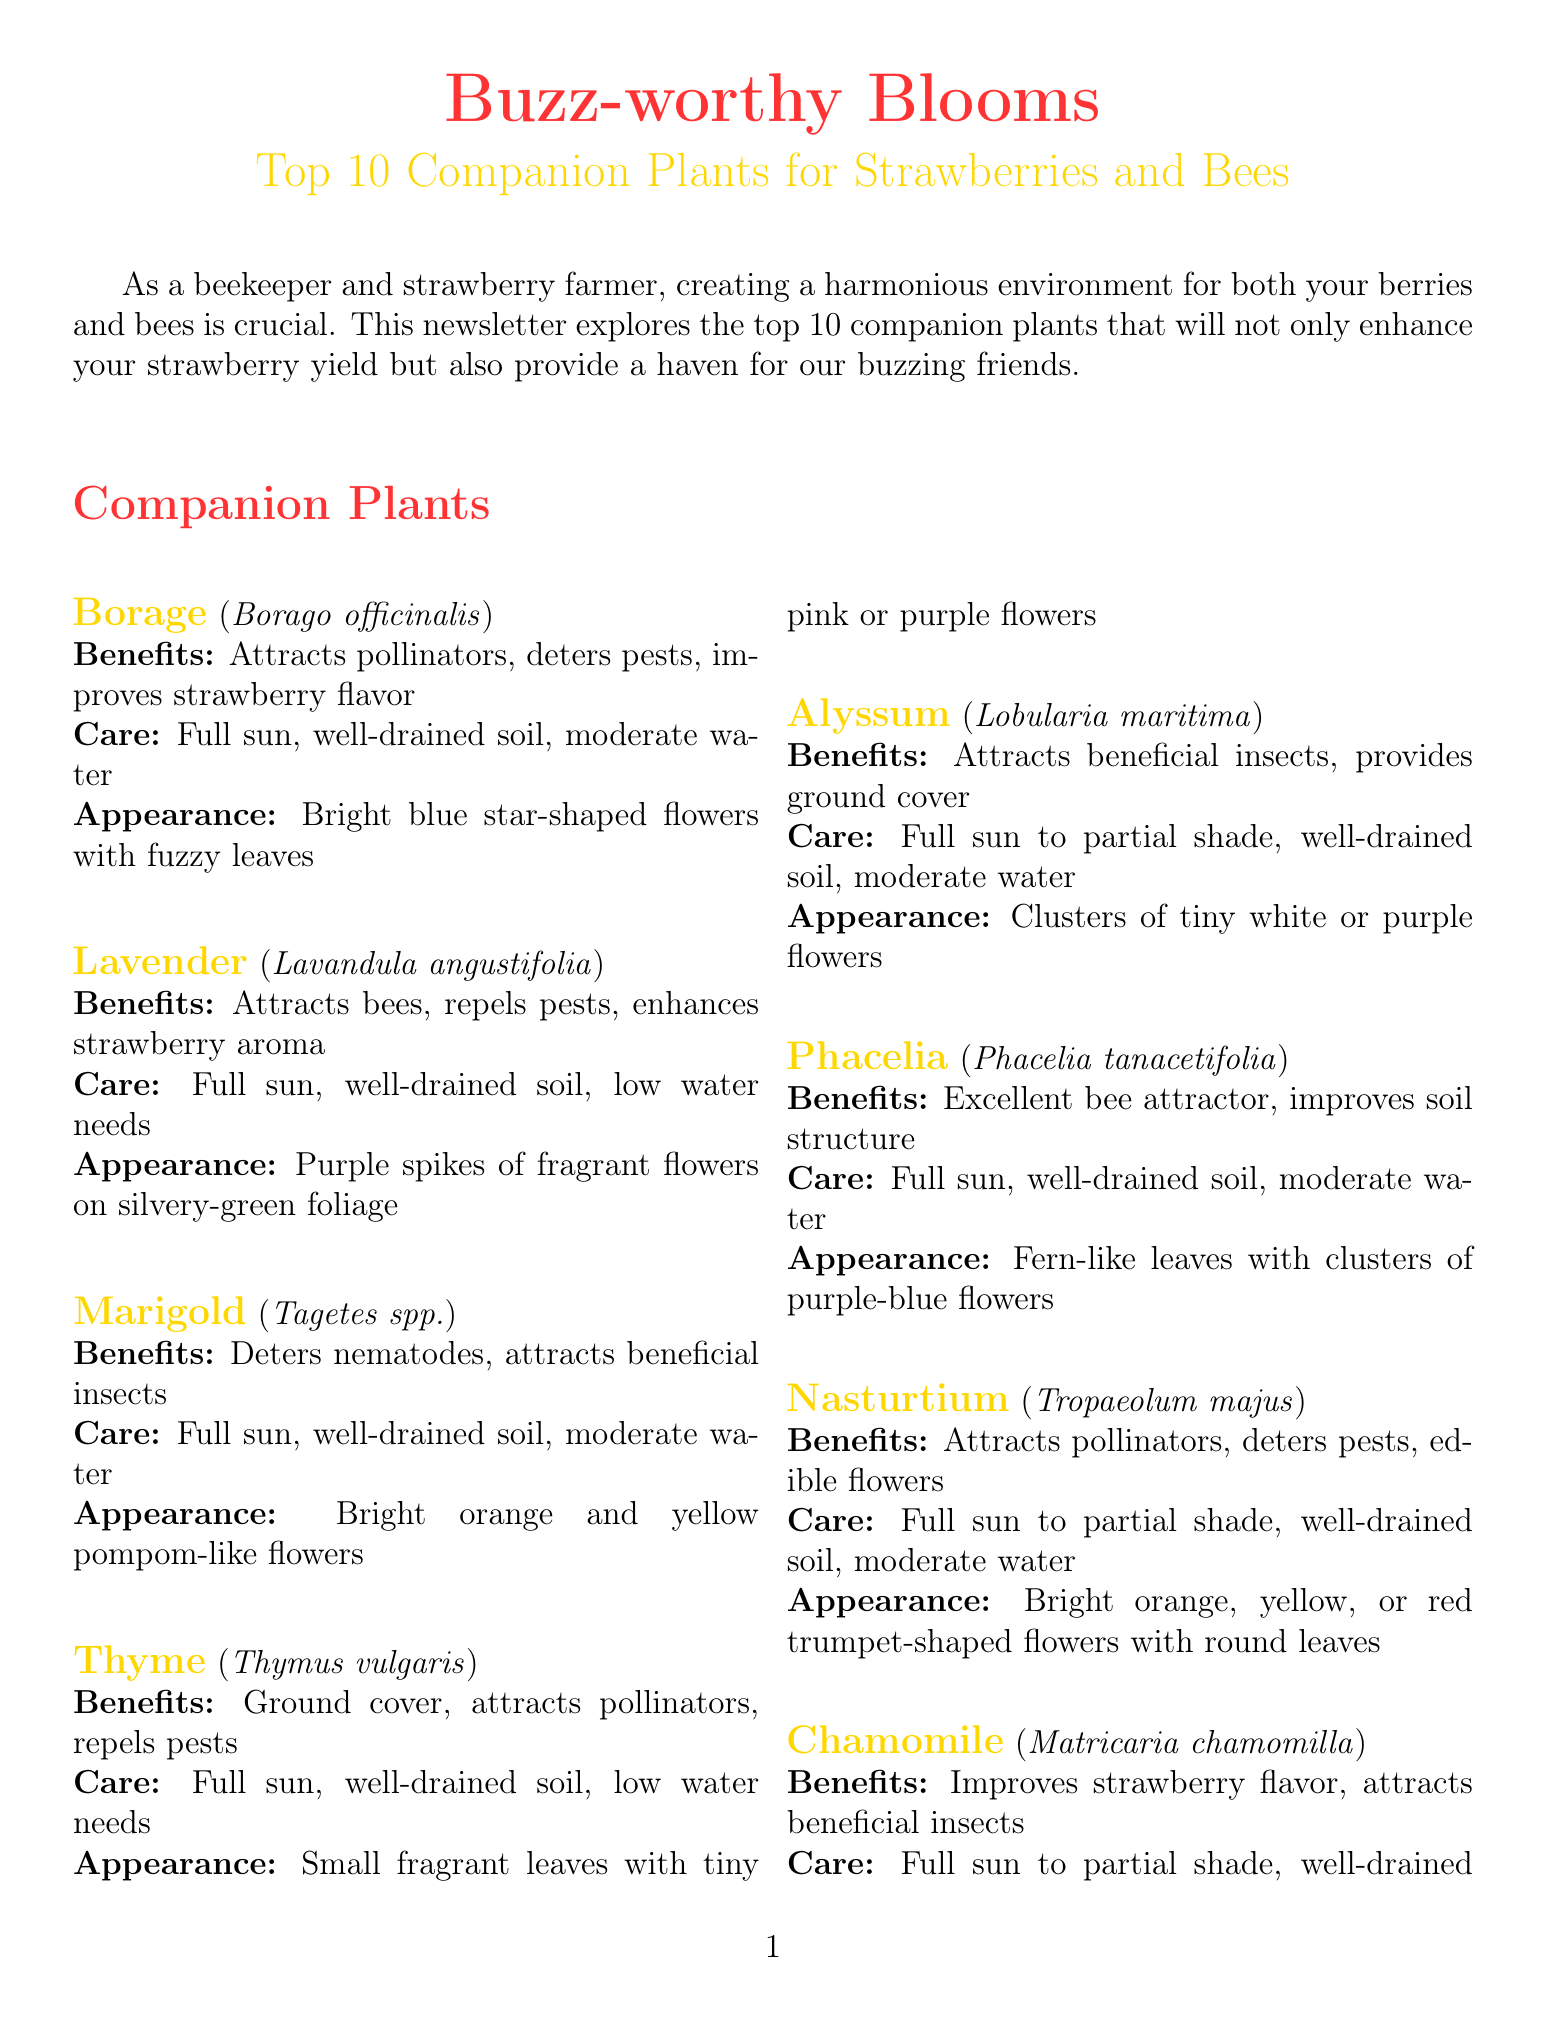What is the title of the newsletter? The title is prominently displayed at the beginning of the document.
Answer: Buzz-worthy Blooms: Top 10 Companion Plants for Strawberries and Bees How many companion plants are listed? The number of companion plants can be found in the section detailing the companion plants.
Answer: 10 What is the scientific name of Lavender? The scientific name is provided alongside each plant's name in the document.
Answer: Lavandula angustifolia Which plant attracts pollinators and deters pests? This information can be found under the benefits of several plants listed.
Answer: Borage What type of soil do most companion plants require? The care instructions for the companion plants generally mention this aspect.
Answer: Well-drained soil Give one benefit of planting Chamomile. The benefits of each plant are clearly detailed in their respective sections.
Answer: Improves strawberry flavor Which companion plant is drought-tolerant once established? This characteristic is noted in the care instructions for one of the plants.
Answer: Coneflower What color are the flowers of Alyssum? The appearance of Alyssum is described in the document.
Answer: White or purple What is one tip for creating a bee-friendly strawberry farm? The tips section suggests various ways to enhance the environment for bees.
Answer: Avoid using pesticides to protect both strawberries and pollinators What is the common name of Echinacea purpurea? Each scientific name is paired with its common name earlier in the document.
Answer: Coneflower 